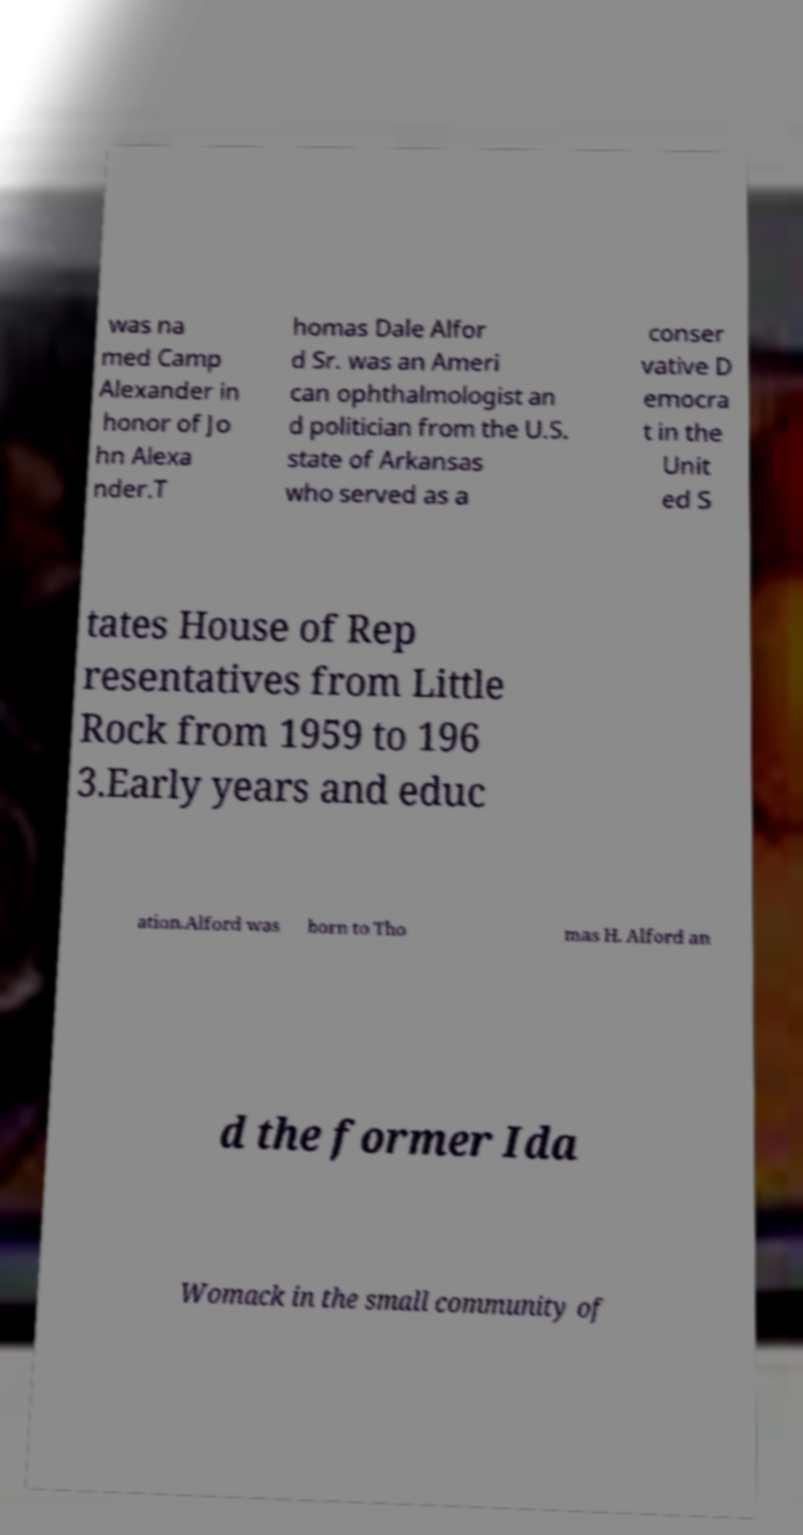Could you assist in decoding the text presented in this image and type it out clearly? was na med Camp Alexander in honor of Jo hn Alexa nder.T homas Dale Alfor d Sr. was an Ameri can ophthalmologist an d politician from the U.S. state of Arkansas who served as a conser vative D emocra t in the Unit ed S tates House of Rep resentatives from Little Rock from 1959 to 196 3.Early years and educ ation.Alford was born to Tho mas H. Alford an d the former Ida Womack in the small community of 